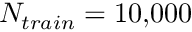Convert formula to latex. <formula><loc_0><loc_0><loc_500><loc_500>N _ { t r a i n } = 1 0 , 0 0 0</formula> 